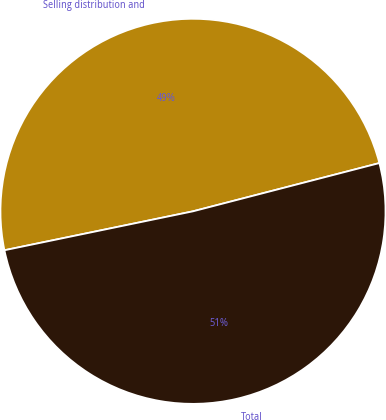Convert chart to OTSL. <chart><loc_0><loc_0><loc_500><loc_500><pie_chart><fcel>Selling distribution and<fcel>Total<nl><fcel>49.21%<fcel>50.79%<nl></chart> 